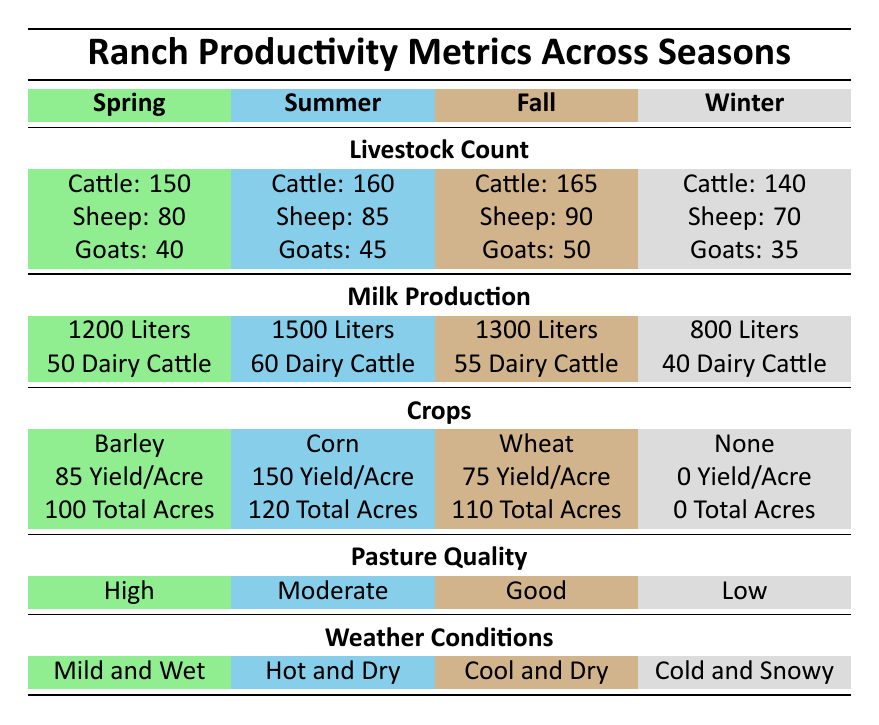What is the total number of cattle across all seasons? The total number of cattle is the sum of cattle in each season: 150 (Spring) + 160 (Summer) + 165 (Fall) + 140 (Winter) = 615.
Answer: 615 What is the yield per acre for crops in the summer? The yield per acre for crops in the summer is directly stated in the table as 150.
Answer: 150 Is there any milk production in winter? According to the table, there is milk production listed as 800 liters in winter, so the statement is true.
Answer: Yes Which season has the highest milk production? By comparing the milk production values listed for each season, summer shows the highest production at 1500 liters.
Answer: Summer What is the difference in the total livestock count between spring and fall? The total livestock count can be calculated for each season: Spring (Cattle: 150 + Sheep: 80 + Goats: 40 = 270) and Fall (Cattle: 165 + Sheep: 90 + Goats: 50 = 305). The difference is 305 (Fall) - 270 (Spring) = 35.
Answer: 35 What is the average yield per acre for crops in spring and fall? The yield per acre for spring is 85 and for fall is 75. To find the average, sum these values (85 + 75) and divide by 2, resulting in (160 / 2) = 80.
Answer: 80 Which season has the lowest pasture quality? The pasture quality in winter is listed as low, which is the lowest among all seasons.
Answer: Winter How many more dairy cattle are there in summer compared to winter? In summer, there are 60 dairy cattle and in winter, there are 40. The difference is 60 - 40 = 20.
Answer: 20 What is the total milk production in fall and winter combined? The milk production in fall is 1300 liters and in winter is 800 liters. The total is 1300 + 800 = 2100 liters.
Answer: 2100 Was there any crop grown during winter? The table clearly states that the crop type in winter is "None," confirming that no crops were grown.
Answer: No 